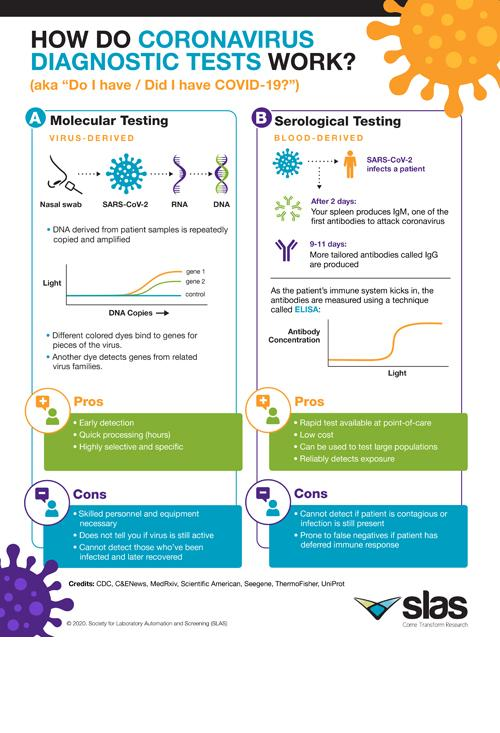Draw attention to some important aspects in this diagram. The base of serological testing involves the use of viruses and blood. Specifically, it involves testing for the presence of antibodies in a sample of blood in order to detect and diagnose certain diseases. Two cons are against serological testing. It is unclear what you are asking. Could you please provide more context or clarify your question? There are three experts who support the use of molecular testing. The base of molecular testing for viruses in blood is... 